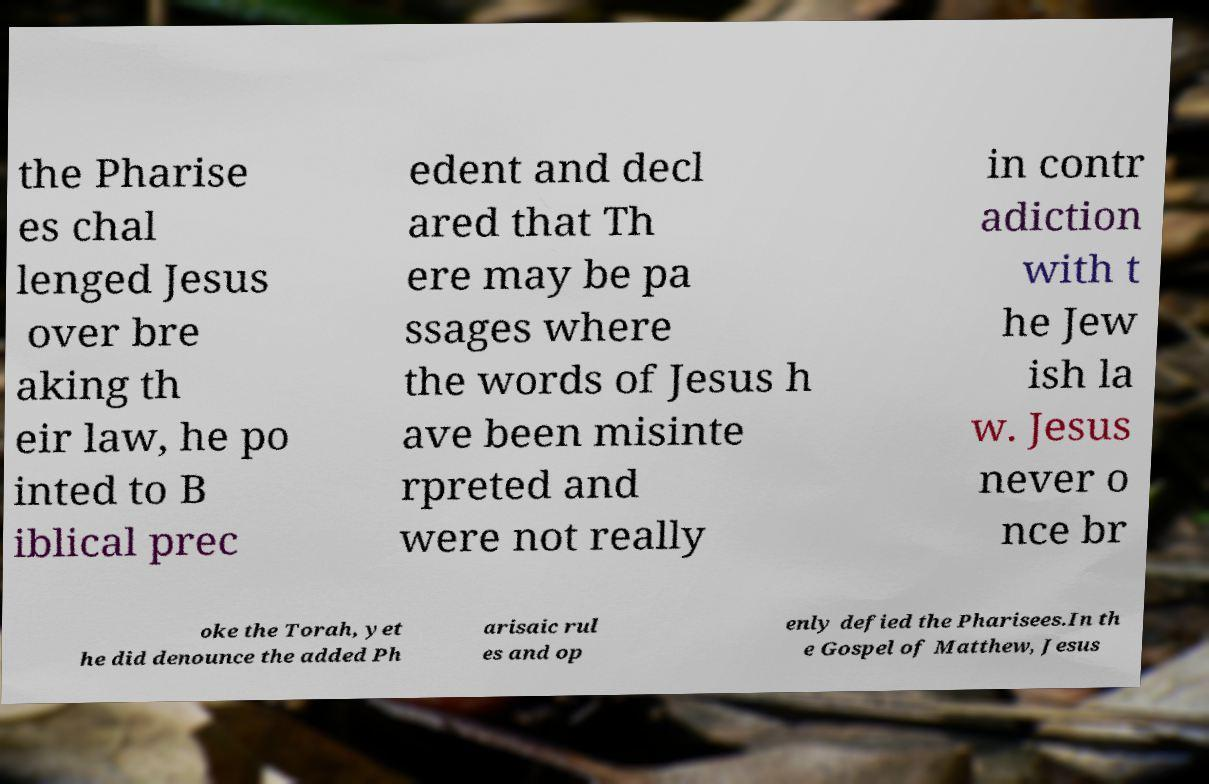What messages or text are displayed in this image? I need them in a readable, typed format. the Pharise es chal lenged Jesus over bre aking th eir law, he po inted to B iblical prec edent and decl ared that Th ere may be pa ssages where the words of Jesus h ave been misinte rpreted and were not really in contr adiction with t he Jew ish la w. Jesus never o nce br oke the Torah, yet he did denounce the added Ph arisaic rul es and op enly defied the Pharisees.In th e Gospel of Matthew, Jesus 